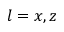Convert formula to latex. <formula><loc_0><loc_0><loc_500><loc_500>l = x , z</formula> 